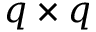<formula> <loc_0><loc_0><loc_500><loc_500>q \times q</formula> 